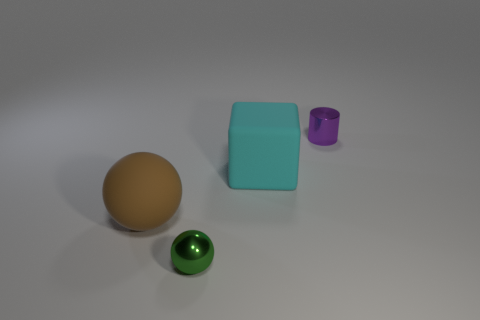There is another big thing that is the same shape as the green metal thing; what is it made of?
Keep it short and to the point. Rubber. Is the big cyan cube made of the same material as the ball behind the green object?
Offer a very short reply. Yes. The green metallic object that is in front of the cyan matte block has what shape?
Offer a very short reply. Sphere. How many other things are made of the same material as the big ball?
Your response must be concise. 1. How big is the shiny cylinder?
Your response must be concise. Small. How many other objects are there of the same color as the rubber sphere?
Your response must be concise. 0. What color is the thing that is both to the left of the small purple cylinder and behind the large brown sphere?
Ensure brevity in your answer.  Cyan. How many big brown objects are there?
Make the answer very short. 1. Does the big sphere have the same material as the cyan thing?
Provide a short and direct response. Yes. The metallic object that is behind the tiny metallic thing that is in front of the tiny thing behind the matte ball is what shape?
Offer a very short reply. Cylinder. 